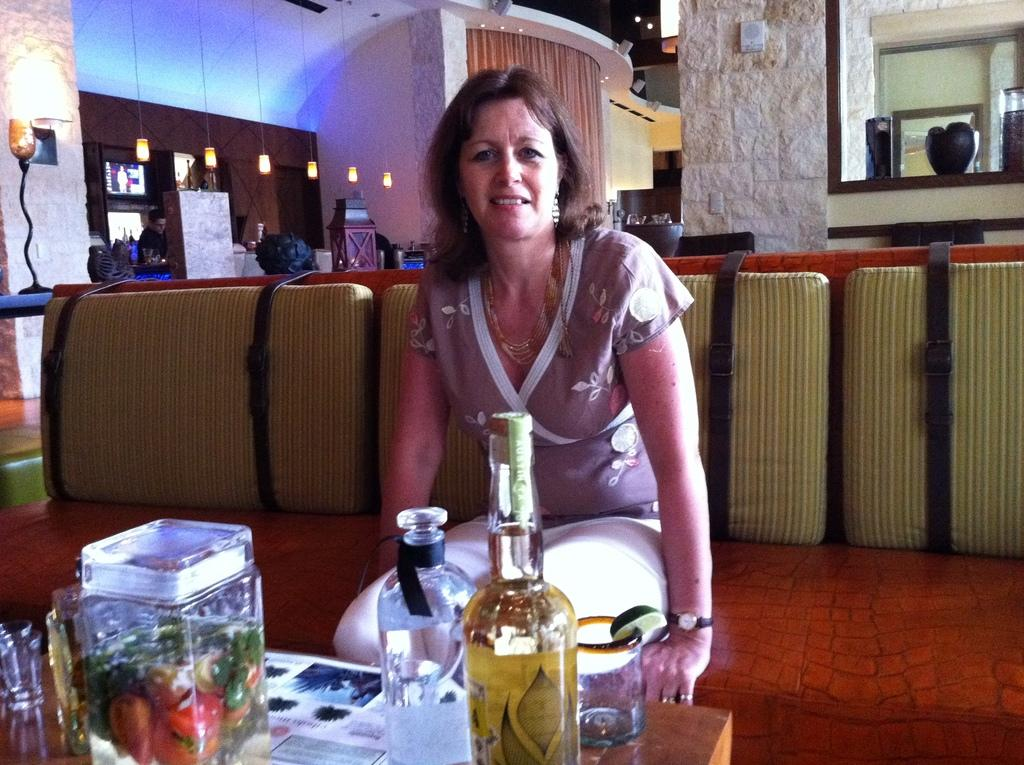What is the woman in the image doing? The woman is sitting on a couch. Can you describe the position of the other person in the image? There is a person standing far from the woman. What electronic device is present in the image? There is a television on a rack. What items can be seen on the table in the image? There is a jar, bottles, and glasses on a table. What can be seen providing illumination in the image? There are lights visible in the image. Where is the faucet located in the image? There is no faucet present in the image. Can you see any steam coming from the television in the image? No, there is no steam visible in the image. 